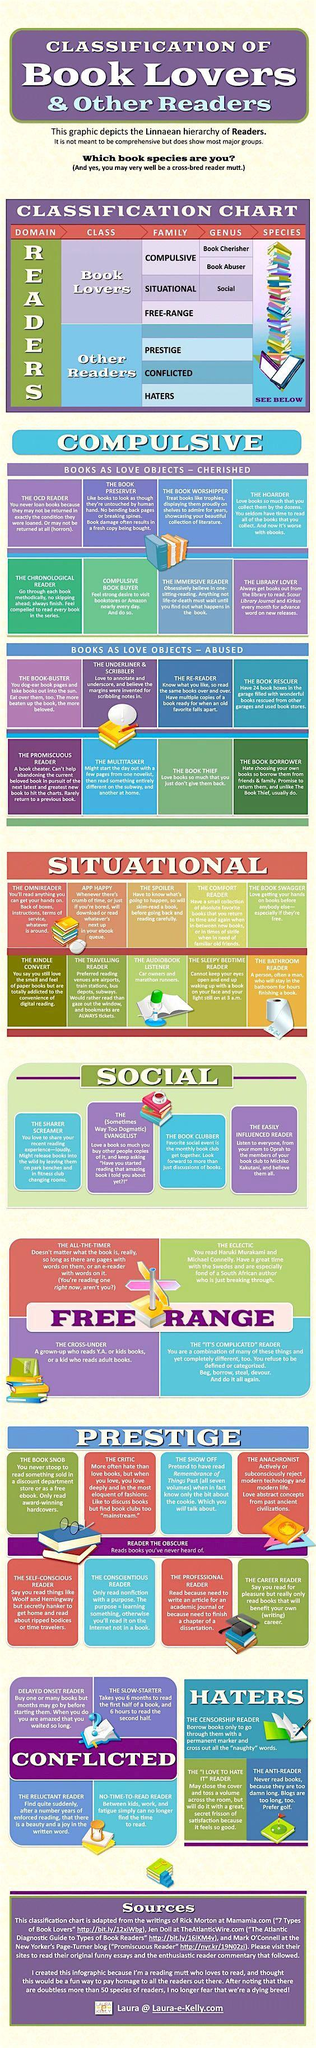List a handful of essential elements in this visual. There are three types of haters mentioned in the infographic. The book preserver is most likely to replace a damaged book with a fresh copy, as they are a compulsive book lover. The career reader group is composed of individuals who exclusively engage in reading books that are beneficial to their careers. The book thief is a compulsive book lover who never returns borrowed books. The book clubber is the third type of social reader. 